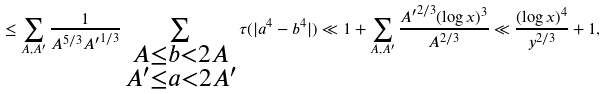Convert formula to latex. <formula><loc_0><loc_0><loc_500><loc_500>\leq \sum _ { A , A ^ { \prime } } \frac { 1 } { A ^ { 5 / 3 } { A ^ { \prime } } ^ { 1 / 3 } } \sum _ { \substack { A \leq b < 2 A \\ A ^ { \prime } \leq a < 2 A ^ { \prime } } } \tau ( | a ^ { 4 } - b ^ { 4 } | ) \ll 1 + \sum _ { A , A ^ { \prime } } \frac { { A ^ { \prime } } ^ { 2 / 3 } ( \log x ) ^ { 3 } } { A ^ { 2 / 3 } } \ll \frac { ( \log x ) ^ { 4 } } { y ^ { 2 / 3 } } + 1 ,</formula> 